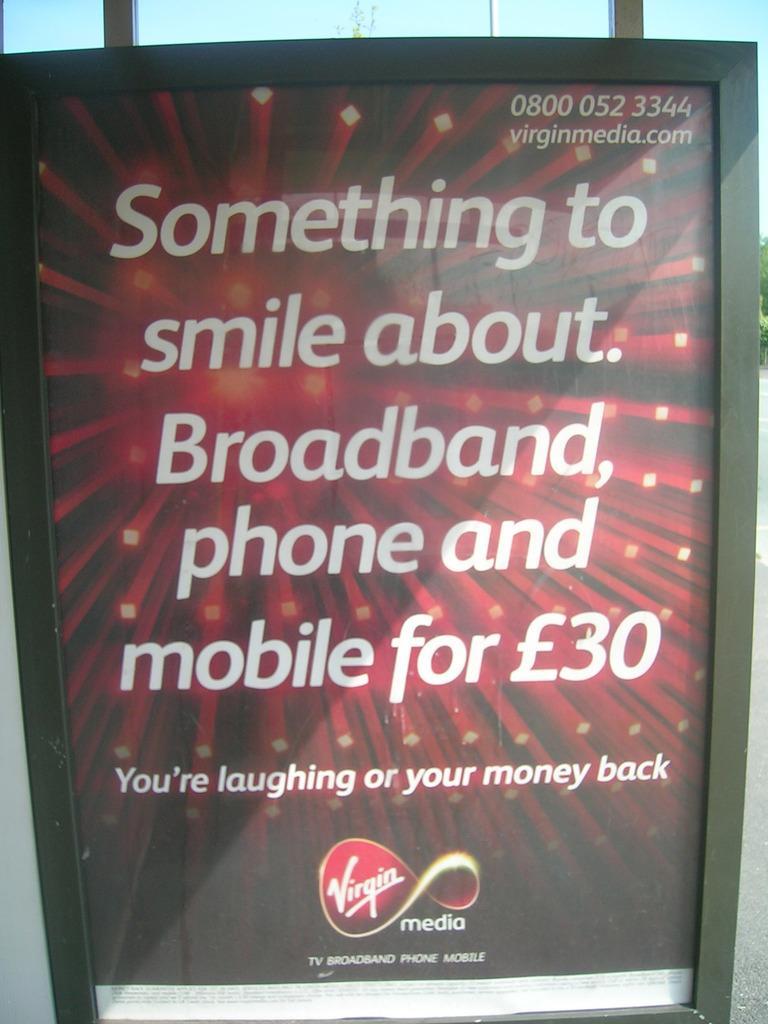How would you summarize this image in a sentence or two? In this picture I can observe digital screen. There is text in the screen. The background is in red color. 